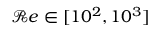Convert formula to latex. <formula><loc_0><loc_0><loc_500><loc_500>\mathcal { R } e \in [ 1 0 ^ { 2 } , 1 0 ^ { 3 } ]</formula> 